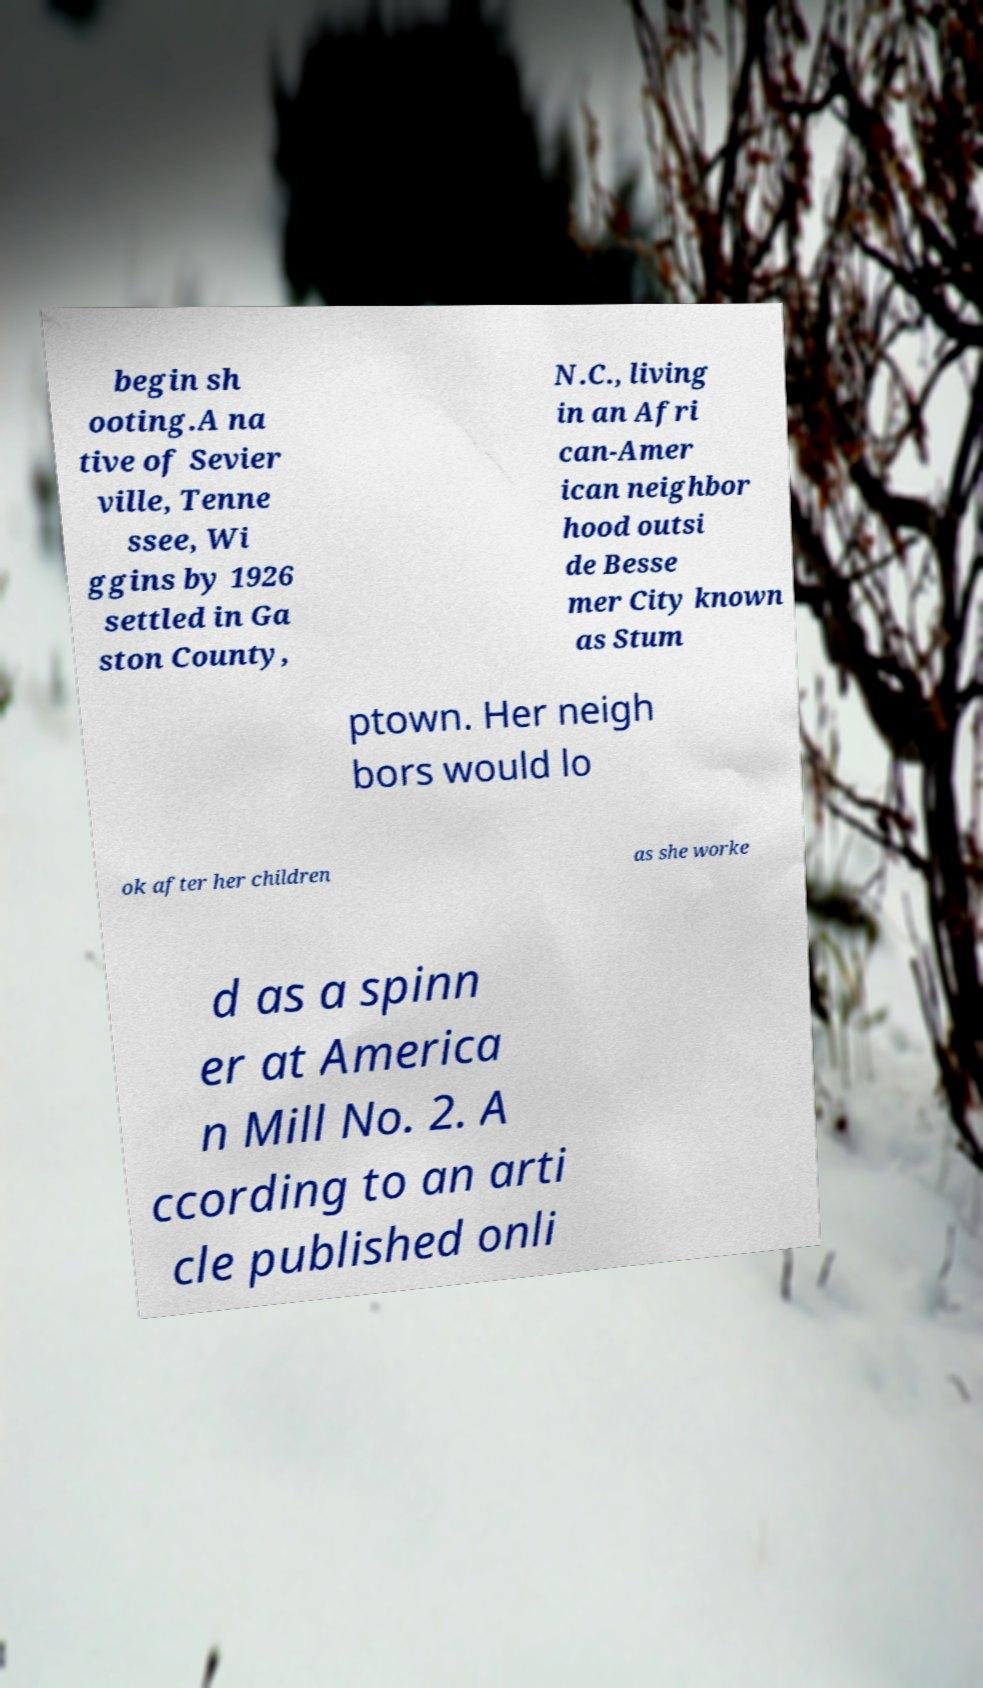For documentation purposes, I need the text within this image transcribed. Could you provide that? begin sh ooting.A na tive of Sevier ville, Tenne ssee, Wi ggins by 1926 settled in Ga ston County, N.C., living in an Afri can-Amer ican neighbor hood outsi de Besse mer City known as Stum ptown. Her neigh bors would lo ok after her children as she worke d as a spinn er at America n Mill No. 2. A ccording to an arti cle published onli 